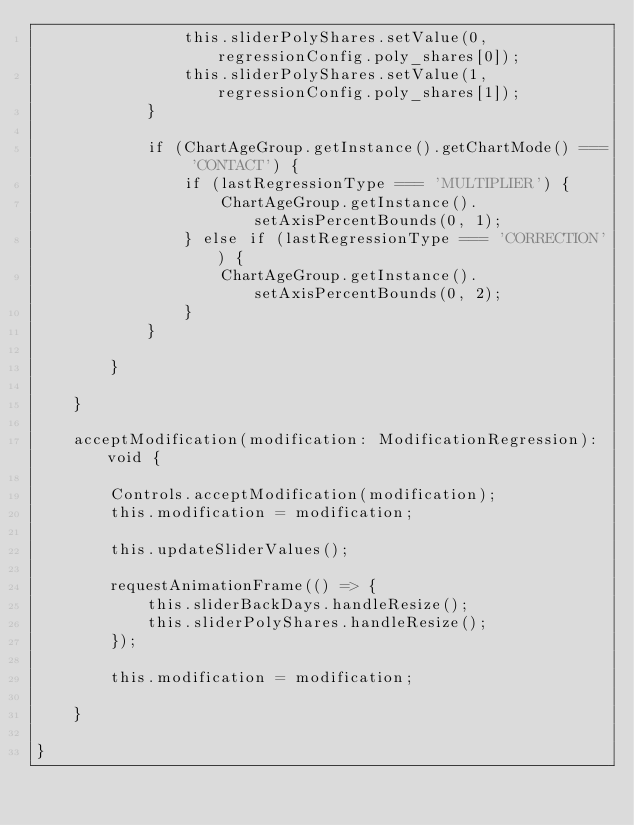<code> <loc_0><loc_0><loc_500><loc_500><_TypeScript_>                this.sliderPolyShares.setValue(0, regressionConfig.poly_shares[0]);
                this.sliderPolyShares.setValue(1, regressionConfig.poly_shares[1]);
            }

            if (ChartAgeGroup.getInstance().getChartMode() === 'CONTACT') {
                if (lastRegressionType === 'MULTIPLIER') {
                    ChartAgeGroup.getInstance().setAxisPercentBounds(0, 1);
                } else if (lastRegressionType === 'CORRECTION') {
                    ChartAgeGroup.getInstance().setAxisPercentBounds(0, 2);
                }
            }

        }

    }

    acceptModification(modification: ModificationRegression): void {

        Controls.acceptModification(modification);
        this.modification = modification;

        this.updateSliderValues();

        requestAnimationFrame(() => {
            this.sliderBackDays.handleResize();
            this.sliderPolyShares.handleResize();
        });

        this.modification = modification;

    }

}</code> 